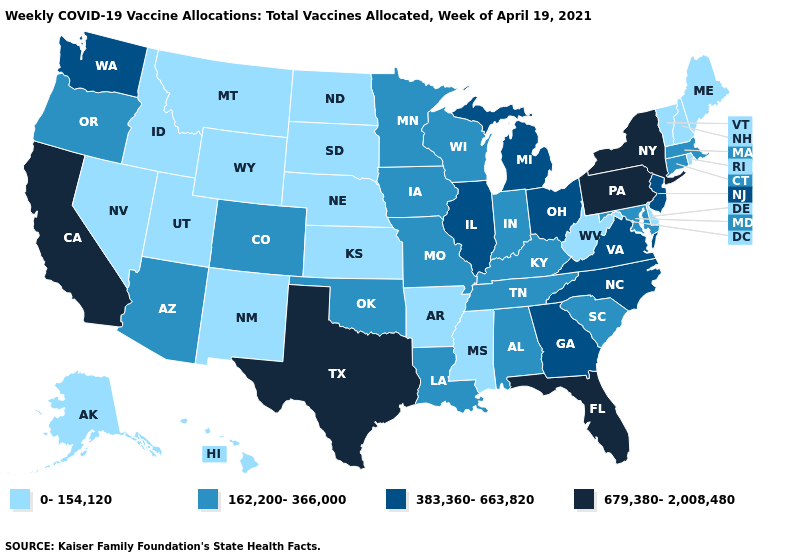Among the states that border Mississippi , does Louisiana have the highest value?
Be succinct. Yes. Name the states that have a value in the range 679,380-2,008,480?
Be succinct. California, Florida, New York, Pennsylvania, Texas. Does the first symbol in the legend represent the smallest category?
Quick response, please. Yes. Which states have the highest value in the USA?
Quick response, please. California, Florida, New York, Pennsylvania, Texas. What is the value of Delaware?
Quick response, please. 0-154,120. Name the states that have a value in the range 162,200-366,000?
Keep it brief. Alabama, Arizona, Colorado, Connecticut, Indiana, Iowa, Kentucky, Louisiana, Maryland, Massachusetts, Minnesota, Missouri, Oklahoma, Oregon, South Carolina, Tennessee, Wisconsin. Among the states that border Illinois , which have the highest value?
Write a very short answer. Indiana, Iowa, Kentucky, Missouri, Wisconsin. What is the lowest value in the South?
Concise answer only. 0-154,120. Among the states that border Ohio , which have the lowest value?
Be succinct. West Virginia. Is the legend a continuous bar?
Keep it brief. No. What is the lowest value in the Northeast?
Be succinct. 0-154,120. What is the highest value in the USA?
Be succinct. 679,380-2,008,480. What is the value of Nebraska?
Write a very short answer. 0-154,120. Name the states that have a value in the range 0-154,120?
Answer briefly. Alaska, Arkansas, Delaware, Hawaii, Idaho, Kansas, Maine, Mississippi, Montana, Nebraska, Nevada, New Hampshire, New Mexico, North Dakota, Rhode Island, South Dakota, Utah, Vermont, West Virginia, Wyoming. Which states have the highest value in the USA?
Answer briefly. California, Florida, New York, Pennsylvania, Texas. 